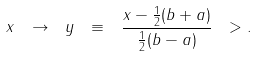Convert formula to latex. <formula><loc_0><loc_0><loc_500><loc_500>x \ \rightarrow \ y \ \equiv \ \frac { x - \frac { 1 } { 2 } ( b + a ) } { \frac { 1 } { 2 } ( b - a ) } \ > .</formula> 